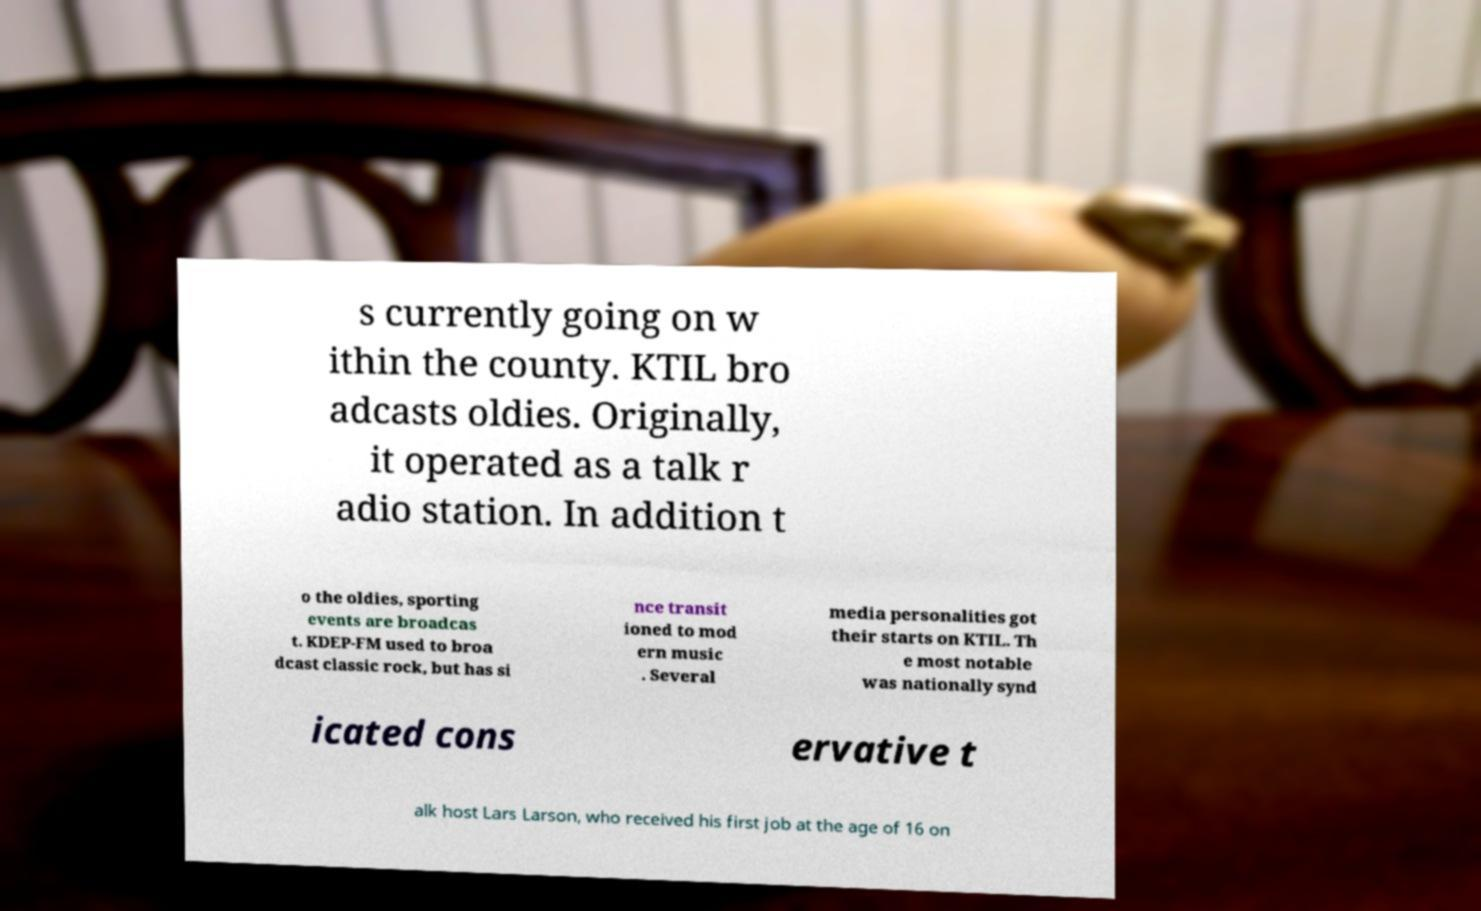Could you assist in decoding the text presented in this image and type it out clearly? s currently going on w ithin the county. KTIL bro adcasts oldies. Originally, it operated as a talk r adio station. In addition t o the oldies, sporting events are broadcas t. KDEP-FM used to broa dcast classic rock, but has si nce transit ioned to mod ern music . Several media personalities got their starts on KTIL. Th e most notable was nationally synd icated cons ervative t alk host Lars Larson, who received his first job at the age of 16 on 